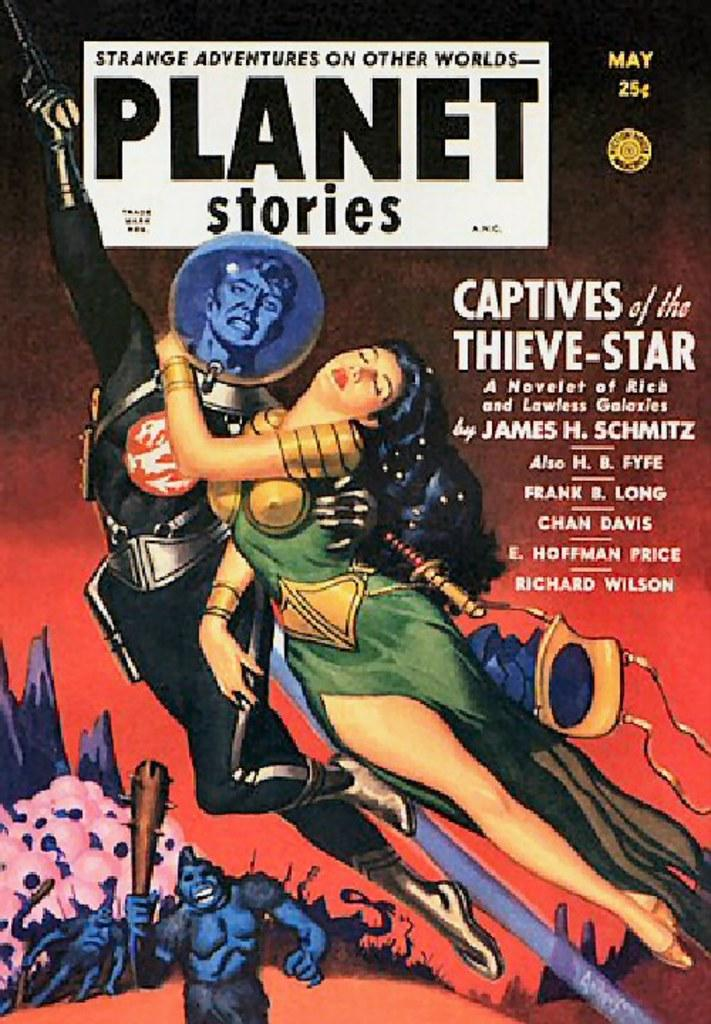<image>
Provide a brief description of the given image. A magazine cover from may called Planet Stories. 